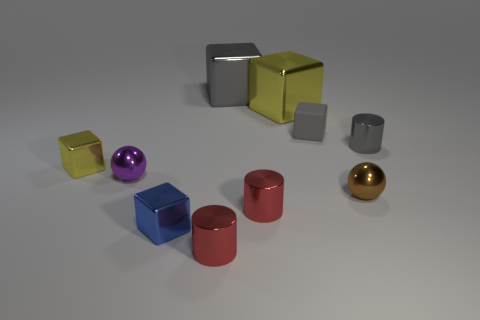Subtract all gray shiny cylinders. How many cylinders are left? 2 Subtract all purple spheres. How many spheres are left? 1 Subtract all spheres. How many objects are left? 8 Subtract 1 balls. How many balls are left? 1 Subtract all gray cubes. Subtract all gray cylinders. How many cubes are left? 3 Subtract all red blocks. How many purple cylinders are left? 0 Subtract all big green objects. Subtract all gray shiny cubes. How many objects are left? 9 Add 1 small blue objects. How many small blue objects are left? 2 Add 3 tiny green rubber spheres. How many tiny green rubber spheres exist? 3 Subtract 1 gray cylinders. How many objects are left? 9 